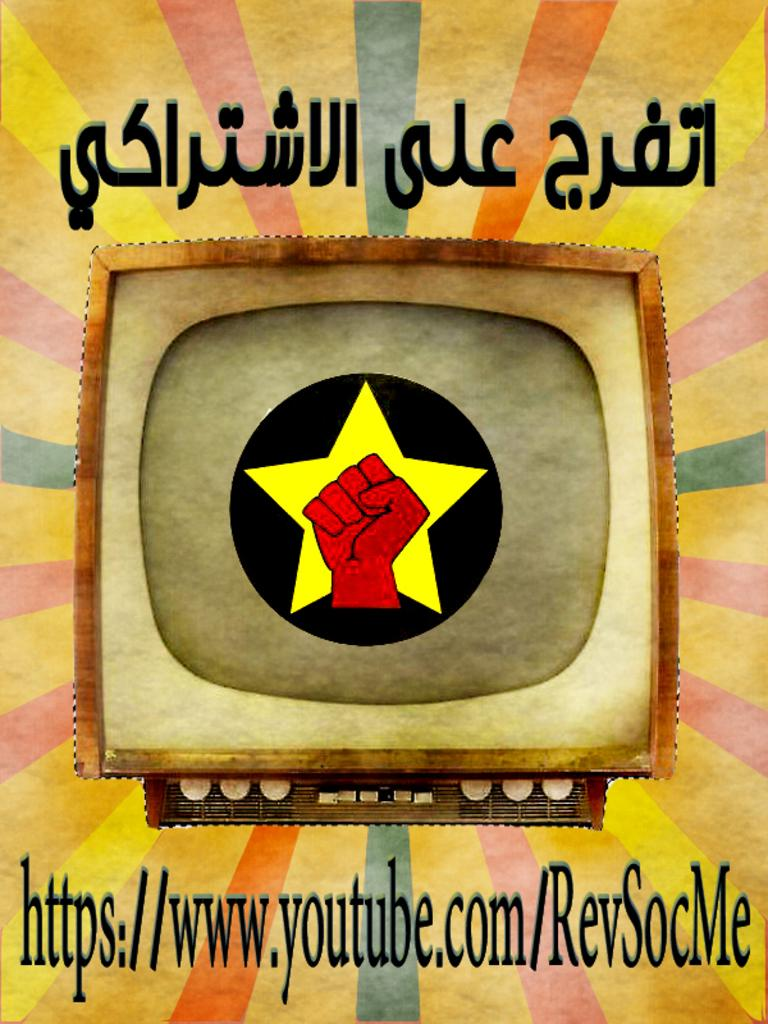<image>
Offer a succinct explanation of the picture presented. Poster that shows a television with a hand and a youtube link on the bottom. 